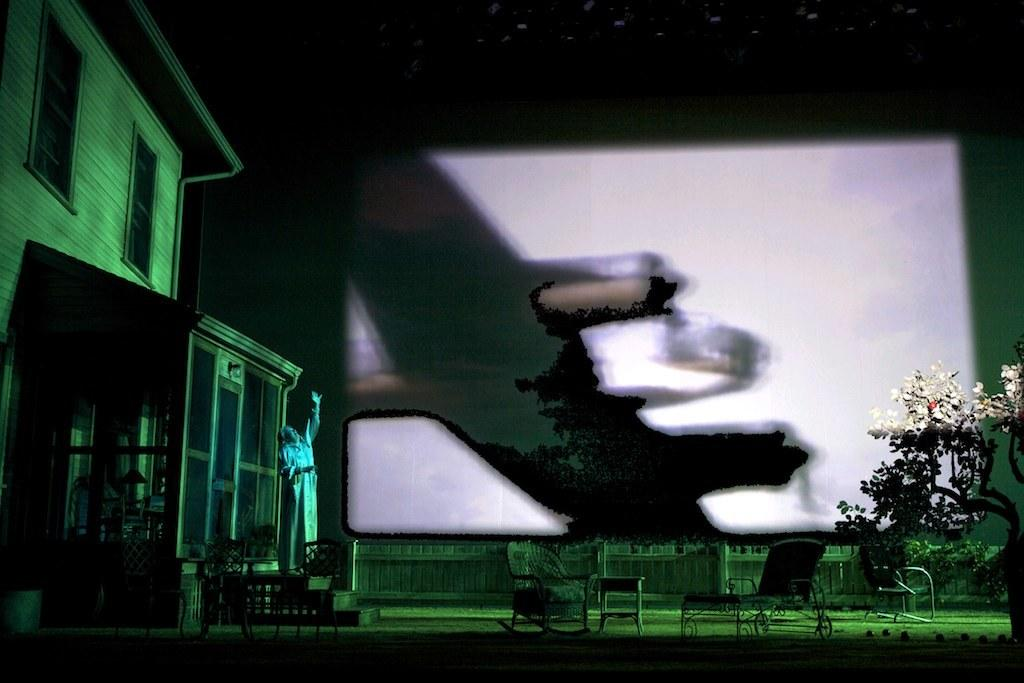What type of structure is present in the image? There is a building in the image. What type of furniture can be seen in the image? There are chairs in the image. What type of natural element is present in the image? There is a tree in the image. Who or what is present in the image? There is a person in the image. What can be seen in the background of the image? There is a screen visible in the background of the image. What type of nail is the person using to teach in the image? There is no nail or teaching activity present in the image. How much dust can be seen on the chairs in the image? There is no mention of dust in the image, and the chairs appear to be clean. 